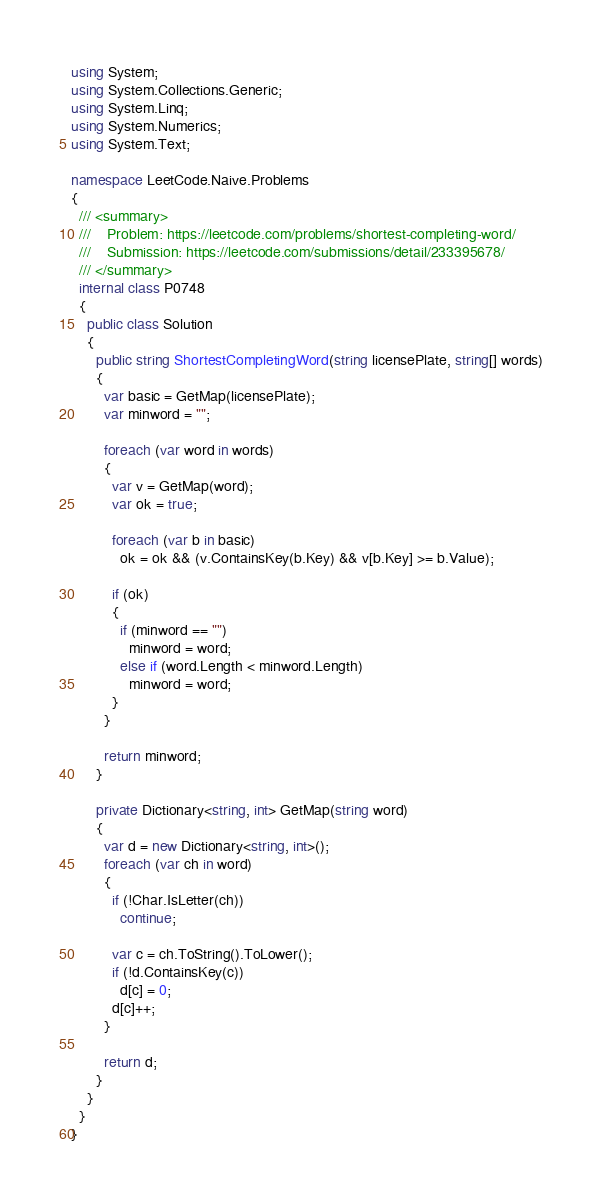Convert code to text. <code><loc_0><loc_0><loc_500><loc_500><_C#_>using System;
using System.Collections.Generic;
using System.Linq;
using System.Numerics;
using System.Text;

namespace LeetCode.Naive.Problems
{
  /// <summary>
  ///    Problem: https://leetcode.com/problems/shortest-completing-word/
  ///    Submission: https://leetcode.com/submissions/detail/233395678/
  /// </summary>
  internal class P0748
  {
    public class Solution
    {
      public string ShortestCompletingWord(string licensePlate, string[] words)
      {
        var basic = GetMap(licensePlate);
        var minword = "";

        foreach (var word in words)
        {
          var v = GetMap(word);
          var ok = true;

          foreach (var b in basic)
            ok = ok && (v.ContainsKey(b.Key) && v[b.Key] >= b.Value);

          if (ok)
          {
            if (minword == "")
              minword = word;
            else if (word.Length < minword.Length)
              minword = word;
          }
        }

        return minword;
      }

      private Dictionary<string, int> GetMap(string word)
      {
        var d = new Dictionary<string, int>();
        foreach (var ch in word)
        {
          if (!Char.IsLetter(ch))
            continue;

          var c = ch.ToString().ToLower();
          if (!d.ContainsKey(c))
            d[c] = 0;
          d[c]++;
        }

        return d;
      }
    }
  }
}
</code> 